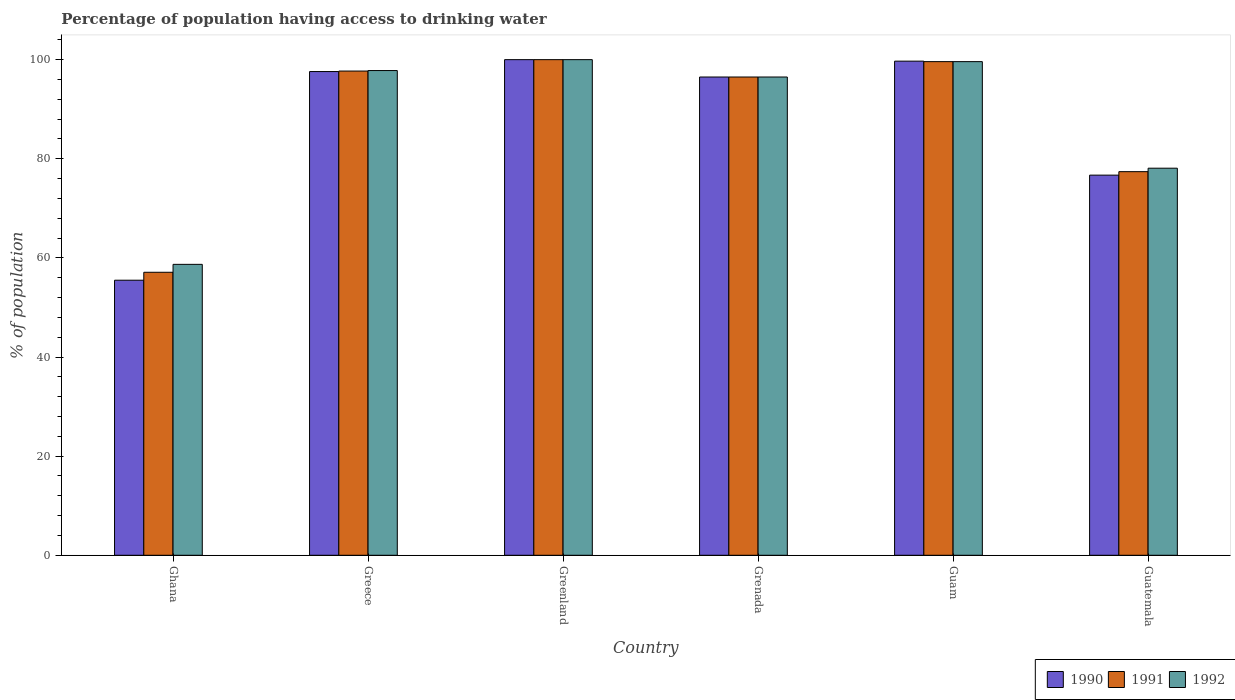How many groups of bars are there?
Make the answer very short. 6. How many bars are there on the 4th tick from the left?
Your response must be concise. 3. How many bars are there on the 4th tick from the right?
Keep it short and to the point. 3. What is the label of the 5th group of bars from the left?
Ensure brevity in your answer.  Guam. What is the percentage of population having access to drinking water in 1992 in Guatemala?
Provide a short and direct response. 78.1. Across all countries, what is the maximum percentage of population having access to drinking water in 1992?
Keep it short and to the point. 100. Across all countries, what is the minimum percentage of population having access to drinking water in 1991?
Keep it short and to the point. 57.1. In which country was the percentage of population having access to drinking water in 1992 maximum?
Offer a terse response. Greenland. In which country was the percentage of population having access to drinking water in 1991 minimum?
Give a very brief answer. Ghana. What is the total percentage of population having access to drinking water in 1992 in the graph?
Ensure brevity in your answer.  530.7. What is the difference between the percentage of population having access to drinking water in 1992 in Greece and that in Guatemala?
Give a very brief answer. 19.7. What is the difference between the percentage of population having access to drinking water in 1992 in Greenland and the percentage of population having access to drinking water in 1991 in Grenada?
Your answer should be very brief. 3.5. What is the average percentage of population having access to drinking water in 1990 per country?
Ensure brevity in your answer.  87.67. What is the difference between the percentage of population having access to drinking water of/in 1990 and percentage of population having access to drinking water of/in 1991 in Greece?
Offer a very short reply. -0.1. In how many countries, is the percentage of population having access to drinking water in 1992 greater than 48 %?
Your answer should be compact. 6. What is the ratio of the percentage of population having access to drinking water in 1990 in Ghana to that in Greece?
Provide a short and direct response. 0.57. Is the difference between the percentage of population having access to drinking water in 1990 in Greece and Guatemala greater than the difference between the percentage of population having access to drinking water in 1991 in Greece and Guatemala?
Give a very brief answer. Yes. What is the difference between the highest and the second highest percentage of population having access to drinking water in 1992?
Provide a succinct answer. -1.8. What is the difference between the highest and the lowest percentage of population having access to drinking water in 1992?
Offer a very short reply. 41.3. In how many countries, is the percentage of population having access to drinking water in 1992 greater than the average percentage of population having access to drinking water in 1992 taken over all countries?
Provide a succinct answer. 4. What does the 3rd bar from the left in Grenada represents?
Provide a short and direct response. 1992. Are all the bars in the graph horizontal?
Offer a terse response. No. Are the values on the major ticks of Y-axis written in scientific E-notation?
Ensure brevity in your answer.  No. Does the graph contain any zero values?
Provide a short and direct response. No. Does the graph contain grids?
Your answer should be very brief. No. Where does the legend appear in the graph?
Ensure brevity in your answer.  Bottom right. What is the title of the graph?
Provide a short and direct response. Percentage of population having access to drinking water. Does "2003" appear as one of the legend labels in the graph?
Your answer should be very brief. No. What is the label or title of the Y-axis?
Your answer should be compact. % of population. What is the % of population of 1990 in Ghana?
Provide a succinct answer. 55.5. What is the % of population of 1991 in Ghana?
Your answer should be compact. 57.1. What is the % of population of 1992 in Ghana?
Ensure brevity in your answer.  58.7. What is the % of population in 1990 in Greece?
Your answer should be compact. 97.6. What is the % of population in 1991 in Greece?
Make the answer very short. 97.7. What is the % of population of 1992 in Greece?
Provide a short and direct response. 97.8. What is the % of population of 1990 in Greenland?
Your answer should be compact. 100. What is the % of population of 1992 in Greenland?
Keep it short and to the point. 100. What is the % of population of 1990 in Grenada?
Give a very brief answer. 96.5. What is the % of population of 1991 in Grenada?
Give a very brief answer. 96.5. What is the % of population of 1992 in Grenada?
Give a very brief answer. 96.5. What is the % of population of 1990 in Guam?
Provide a succinct answer. 99.7. What is the % of population of 1991 in Guam?
Offer a very short reply. 99.6. What is the % of population of 1992 in Guam?
Your answer should be very brief. 99.6. What is the % of population of 1990 in Guatemala?
Give a very brief answer. 76.7. What is the % of population of 1991 in Guatemala?
Your answer should be compact. 77.4. What is the % of population of 1992 in Guatemala?
Your answer should be compact. 78.1. Across all countries, what is the maximum % of population in 1991?
Offer a very short reply. 100. Across all countries, what is the maximum % of population in 1992?
Offer a very short reply. 100. Across all countries, what is the minimum % of population of 1990?
Offer a terse response. 55.5. Across all countries, what is the minimum % of population of 1991?
Offer a very short reply. 57.1. Across all countries, what is the minimum % of population of 1992?
Ensure brevity in your answer.  58.7. What is the total % of population in 1990 in the graph?
Your answer should be compact. 526. What is the total % of population of 1991 in the graph?
Keep it short and to the point. 528.3. What is the total % of population in 1992 in the graph?
Make the answer very short. 530.7. What is the difference between the % of population of 1990 in Ghana and that in Greece?
Keep it short and to the point. -42.1. What is the difference between the % of population in 1991 in Ghana and that in Greece?
Your answer should be compact. -40.6. What is the difference between the % of population of 1992 in Ghana and that in Greece?
Offer a very short reply. -39.1. What is the difference between the % of population in 1990 in Ghana and that in Greenland?
Your answer should be compact. -44.5. What is the difference between the % of population in 1991 in Ghana and that in Greenland?
Make the answer very short. -42.9. What is the difference between the % of population in 1992 in Ghana and that in Greenland?
Your answer should be very brief. -41.3. What is the difference between the % of population of 1990 in Ghana and that in Grenada?
Provide a short and direct response. -41. What is the difference between the % of population in 1991 in Ghana and that in Grenada?
Offer a terse response. -39.4. What is the difference between the % of population in 1992 in Ghana and that in Grenada?
Offer a very short reply. -37.8. What is the difference between the % of population in 1990 in Ghana and that in Guam?
Offer a terse response. -44.2. What is the difference between the % of population in 1991 in Ghana and that in Guam?
Provide a succinct answer. -42.5. What is the difference between the % of population of 1992 in Ghana and that in Guam?
Ensure brevity in your answer.  -40.9. What is the difference between the % of population of 1990 in Ghana and that in Guatemala?
Keep it short and to the point. -21.2. What is the difference between the % of population in 1991 in Ghana and that in Guatemala?
Your answer should be very brief. -20.3. What is the difference between the % of population of 1992 in Ghana and that in Guatemala?
Your answer should be compact. -19.4. What is the difference between the % of population of 1990 in Greece and that in Greenland?
Your response must be concise. -2.4. What is the difference between the % of population of 1991 in Greece and that in Greenland?
Give a very brief answer. -2.3. What is the difference between the % of population in 1992 in Greece and that in Greenland?
Offer a terse response. -2.2. What is the difference between the % of population in 1991 in Greece and that in Guam?
Your answer should be very brief. -1.9. What is the difference between the % of population of 1990 in Greece and that in Guatemala?
Make the answer very short. 20.9. What is the difference between the % of population in 1991 in Greece and that in Guatemala?
Your response must be concise. 20.3. What is the difference between the % of population in 1990 in Greenland and that in Grenada?
Your answer should be very brief. 3.5. What is the difference between the % of population of 1992 in Greenland and that in Grenada?
Your answer should be very brief. 3.5. What is the difference between the % of population in 1991 in Greenland and that in Guam?
Your answer should be very brief. 0.4. What is the difference between the % of population of 1990 in Greenland and that in Guatemala?
Your answer should be very brief. 23.3. What is the difference between the % of population in 1991 in Greenland and that in Guatemala?
Keep it short and to the point. 22.6. What is the difference between the % of population in 1992 in Greenland and that in Guatemala?
Provide a short and direct response. 21.9. What is the difference between the % of population in 1990 in Grenada and that in Guam?
Ensure brevity in your answer.  -3.2. What is the difference between the % of population of 1991 in Grenada and that in Guam?
Provide a succinct answer. -3.1. What is the difference between the % of population of 1992 in Grenada and that in Guam?
Keep it short and to the point. -3.1. What is the difference between the % of population in 1990 in Grenada and that in Guatemala?
Ensure brevity in your answer.  19.8. What is the difference between the % of population of 1991 in Guam and that in Guatemala?
Make the answer very short. 22.2. What is the difference between the % of population in 1992 in Guam and that in Guatemala?
Ensure brevity in your answer.  21.5. What is the difference between the % of population of 1990 in Ghana and the % of population of 1991 in Greece?
Your response must be concise. -42.2. What is the difference between the % of population in 1990 in Ghana and the % of population in 1992 in Greece?
Keep it short and to the point. -42.3. What is the difference between the % of population of 1991 in Ghana and the % of population of 1992 in Greece?
Your answer should be compact. -40.7. What is the difference between the % of population in 1990 in Ghana and the % of population in 1991 in Greenland?
Provide a succinct answer. -44.5. What is the difference between the % of population in 1990 in Ghana and the % of population in 1992 in Greenland?
Your response must be concise. -44.5. What is the difference between the % of population in 1991 in Ghana and the % of population in 1992 in Greenland?
Ensure brevity in your answer.  -42.9. What is the difference between the % of population in 1990 in Ghana and the % of population in 1991 in Grenada?
Provide a succinct answer. -41. What is the difference between the % of population in 1990 in Ghana and the % of population in 1992 in Grenada?
Keep it short and to the point. -41. What is the difference between the % of population of 1991 in Ghana and the % of population of 1992 in Grenada?
Your answer should be compact. -39.4. What is the difference between the % of population in 1990 in Ghana and the % of population in 1991 in Guam?
Your answer should be very brief. -44.1. What is the difference between the % of population in 1990 in Ghana and the % of population in 1992 in Guam?
Provide a short and direct response. -44.1. What is the difference between the % of population in 1991 in Ghana and the % of population in 1992 in Guam?
Your answer should be compact. -42.5. What is the difference between the % of population of 1990 in Ghana and the % of population of 1991 in Guatemala?
Ensure brevity in your answer.  -21.9. What is the difference between the % of population in 1990 in Ghana and the % of population in 1992 in Guatemala?
Your answer should be compact. -22.6. What is the difference between the % of population of 1990 in Greece and the % of population of 1991 in Greenland?
Your response must be concise. -2.4. What is the difference between the % of population in 1990 in Greece and the % of population in 1992 in Greenland?
Provide a short and direct response. -2.4. What is the difference between the % of population of 1990 in Greece and the % of population of 1991 in Grenada?
Your answer should be compact. 1.1. What is the difference between the % of population of 1991 in Greece and the % of population of 1992 in Grenada?
Provide a succinct answer. 1.2. What is the difference between the % of population of 1990 in Greece and the % of population of 1991 in Guam?
Make the answer very short. -2. What is the difference between the % of population in 1991 in Greece and the % of population in 1992 in Guam?
Your answer should be very brief. -1.9. What is the difference between the % of population in 1990 in Greece and the % of population in 1991 in Guatemala?
Provide a short and direct response. 20.2. What is the difference between the % of population in 1990 in Greece and the % of population in 1992 in Guatemala?
Your answer should be very brief. 19.5. What is the difference between the % of population of 1991 in Greece and the % of population of 1992 in Guatemala?
Offer a very short reply. 19.6. What is the difference between the % of population of 1990 in Greenland and the % of population of 1992 in Grenada?
Make the answer very short. 3.5. What is the difference between the % of population in 1991 in Greenland and the % of population in 1992 in Guam?
Make the answer very short. 0.4. What is the difference between the % of population in 1990 in Greenland and the % of population in 1991 in Guatemala?
Offer a very short reply. 22.6. What is the difference between the % of population in 1990 in Greenland and the % of population in 1992 in Guatemala?
Offer a very short reply. 21.9. What is the difference between the % of population of 1991 in Greenland and the % of population of 1992 in Guatemala?
Offer a terse response. 21.9. What is the difference between the % of population in 1990 in Grenada and the % of population in 1992 in Guam?
Give a very brief answer. -3.1. What is the difference between the % of population in 1991 in Grenada and the % of population in 1992 in Guam?
Give a very brief answer. -3.1. What is the difference between the % of population in 1990 in Grenada and the % of population in 1992 in Guatemala?
Keep it short and to the point. 18.4. What is the difference between the % of population in 1991 in Grenada and the % of population in 1992 in Guatemala?
Provide a succinct answer. 18.4. What is the difference between the % of population in 1990 in Guam and the % of population in 1991 in Guatemala?
Offer a terse response. 22.3. What is the difference between the % of population of 1990 in Guam and the % of population of 1992 in Guatemala?
Offer a very short reply. 21.6. What is the average % of population of 1990 per country?
Your answer should be compact. 87.67. What is the average % of population in 1991 per country?
Ensure brevity in your answer.  88.05. What is the average % of population in 1992 per country?
Ensure brevity in your answer.  88.45. What is the difference between the % of population in 1991 and % of population in 1992 in Ghana?
Make the answer very short. -1.6. What is the difference between the % of population of 1990 and % of population of 1991 in Greece?
Your answer should be compact. -0.1. What is the difference between the % of population in 1990 and % of population in 1992 in Greece?
Ensure brevity in your answer.  -0.2. What is the difference between the % of population of 1990 and % of population of 1992 in Greenland?
Give a very brief answer. 0. What is the difference between the % of population in 1991 and % of population in 1992 in Greenland?
Keep it short and to the point. 0. What is the difference between the % of population of 1990 and % of population of 1991 in Grenada?
Ensure brevity in your answer.  0. What is the difference between the % of population in 1990 and % of population in 1991 in Guam?
Keep it short and to the point. 0.1. What is the difference between the % of population of 1990 and % of population of 1992 in Guam?
Your answer should be compact. 0.1. What is the difference between the % of population in 1991 and % of population in 1992 in Guam?
Provide a short and direct response. 0. What is the difference between the % of population in 1990 and % of population in 1991 in Guatemala?
Provide a succinct answer. -0.7. What is the difference between the % of population in 1991 and % of population in 1992 in Guatemala?
Ensure brevity in your answer.  -0.7. What is the ratio of the % of population in 1990 in Ghana to that in Greece?
Your response must be concise. 0.57. What is the ratio of the % of population of 1991 in Ghana to that in Greece?
Your answer should be compact. 0.58. What is the ratio of the % of population in 1992 in Ghana to that in Greece?
Your response must be concise. 0.6. What is the ratio of the % of population of 1990 in Ghana to that in Greenland?
Give a very brief answer. 0.56. What is the ratio of the % of population of 1991 in Ghana to that in Greenland?
Give a very brief answer. 0.57. What is the ratio of the % of population in 1992 in Ghana to that in Greenland?
Make the answer very short. 0.59. What is the ratio of the % of population of 1990 in Ghana to that in Grenada?
Ensure brevity in your answer.  0.58. What is the ratio of the % of population of 1991 in Ghana to that in Grenada?
Your response must be concise. 0.59. What is the ratio of the % of population of 1992 in Ghana to that in Grenada?
Offer a terse response. 0.61. What is the ratio of the % of population in 1990 in Ghana to that in Guam?
Ensure brevity in your answer.  0.56. What is the ratio of the % of population in 1991 in Ghana to that in Guam?
Keep it short and to the point. 0.57. What is the ratio of the % of population in 1992 in Ghana to that in Guam?
Your answer should be compact. 0.59. What is the ratio of the % of population of 1990 in Ghana to that in Guatemala?
Make the answer very short. 0.72. What is the ratio of the % of population of 1991 in Ghana to that in Guatemala?
Give a very brief answer. 0.74. What is the ratio of the % of population of 1992 in Ghana to that in Guatemala?
Offer a terse response. 0.75. What is the ratio of the % of population of 1992 in Greece to that in Greenland?
Ensure brevity in your answer.  0.98. What is the ratio of the % of population in 1990 in Greece to that in Grenada?
Your answer should be compact. 1.01. What is the ratio of the % of population of 1991 in Greece to that in Grenada?
Your answer should be very brief. 1.01. What is the ratio of the % of population of 1992 in Greece to that in Grenada?
Give a very brief answer. 1.01. What is the ratio of the % of population in 1990 in Greece to that in Guam?
Keep it short and to the point. 0.98. What is the ratio of the % of population in 1991 in Greece to that in Guam?
Make the answer very short. 0.98. What is the ratio of the % of population of 1992 in Greece to that in Guam?
Offer a very short reply. 0.98. What is the ratio of the % of population of 1990 in Greece to that in Guatemala?
Your answer should be compact. 1.27. What is the ratio of the % of population in 1991 in Greece to that in Guatemala?
Offer a terse response. 1.26. What is the ratio of the % of population in 1992 in Greece to that in Guatemala?
Offer a very short reply. 1.25. What is the ratio of the % of population in 1990 in Greenland to that in Grenada?
Make the answer very short. 1.04. What is the ratio of the % of population in 1991 in Greenland to that in Grenada?
Offer a terse response. 1.04. What is the ratio of the % of population of 1992 in Greenland to that in Grenada?
Give a very brief answer. 1.04. What is the ratio of the % of population in 1990 in Greenland to that in Guam?
Provide a succinct answer. 1. What is the ratio of the % of population in 1991 in Greenland to that in Guam?
Your answer should be compact. 1. What is the ratio of the % of population in 1992 in Greenland to that in Guam?
Make the answer very short. 1. What is the ratio of the % of population of 1990 in Greenland to that in Guatemala?
Ensure brevity in your answer.  1.3. What is the ratio of the % of population of 1991 in Greenland to that in Guatemala?
Your answer should be compact. 1.29. What is the ratio of the % of population of 1992 in Greenland to that in Guatemala?
Provide a short and direct response. 1.28. What is the ratio of the % of population in 1990 in Grenada to that in Guam?
Offer a very short reply. 0.97. What is the ratio of the % of population of 1991 in Grenada to that in Guam?
Keep it short and to the point. 0.97. What is the ratio of the % of population in 1992 in Grenada to that in Guam?
Your answer should be compact. 0.97. What is the ratio of the % of population of 1990 in Grenada to that in Guatemala?
Your answer should be compact. 1.26. What is the ratio of the % of population of 1991 in Grenada to that in Guatemala?
Ensure brevity in your answer.  1.25. What is the ratio of the % of population of 1992 in Grenada to that in Guatemala?
Your answer should be very brief. 1.24. What is the ratio of the % of population of 1990 in Guam to that in Guatemala?
Give a very brief answer. 1.3. What is the ratio of the % of population in 1991 in Guam to that in Guatemala?
Your response must be concise. 1.29. What is the ratio of the % of population of 1992 in Guam to that in Guatemala?
Make the answer very short. 1.28. What is the difference between the highest and the lowest % of population in 1990?
Provide a short and direct response. 44.5. What is the difference between the highest and the lowest % of population in 1991?
Provide a succinct answer. 42.9. What is the difference between the highest and the lowest % of population in 1992?
Offer a very short reply. 41.3. 